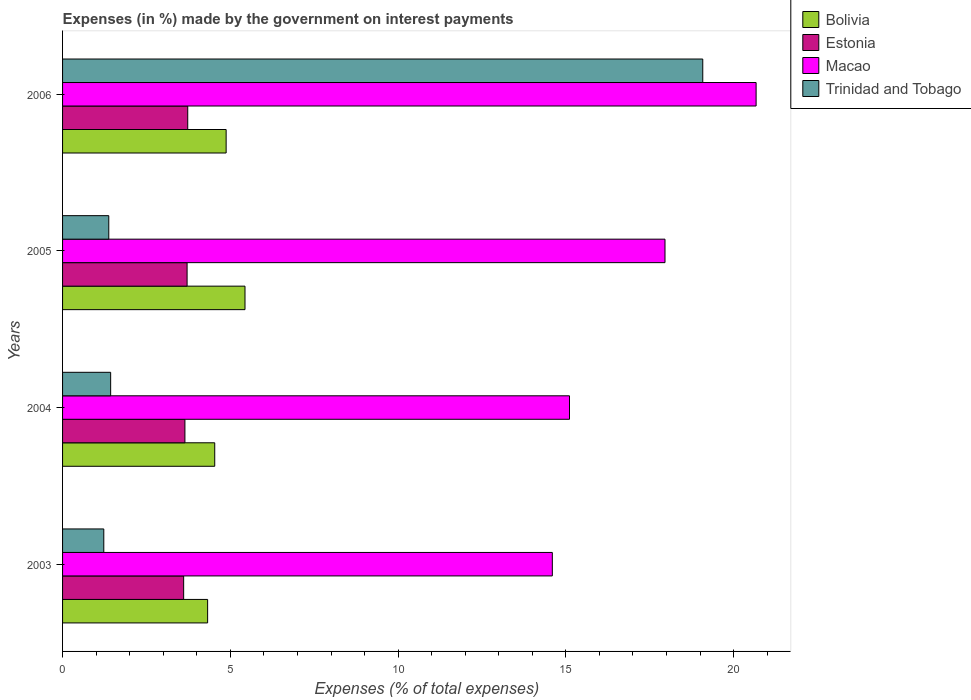How many bars are there on the 4th tick from the top?
Offer a very short reply. 4. How many bars are there on the 2nd tick from the bottom?
Offer a very short reply. 4. What is the label of the 4th group of bars from the top?
Offer a very short reply. 2003. In how many cases, is the number of bars for a given year not equal to the number of legend labels?
Your answer should be very brief. 0. What is the percentage of expenses made by the government on interest payments in Trinidad and Tobago in 2005?
Your response must be concise. 1.38. Across all years, what is the maximum percentage of expenses made by the government on interest payments in Macao?
Your answer should be very brief. 20.67. Across all years, what is the minimum percentage of expenses made by the government on interest payments in Estonia?
Offer a terse response. 3.61. In which year was the percentage of expenses made by the government on interest payments in Trinidad and Tobago maximum?
Your answer should be very brief. 2006. What is the total percentage of expenses made by the government on interest payments in Estonia in the graph?
Provide a succinct answer. 14.7. What is the difference between the percentage of expenses made by the government on interest payments in Trinidad and Tobago in 2003 and that in 2006?
Make the answer very short. -17.85. What is the difference between the percentage of expenses made by the government on interest payments in Trinidad and Tobago in 2006 and the percentage of expenses made by the government on interest payments in Macao in 2003?
Offer a terse response. 4.48. What is the average percentage of expenses made by the government on interest payments in Estonia per year?
Provide a succinct answer. 3.67. In the year 2005, what is the difference between the percentage of expenses made by the government on interest payments in Macao and percentage of expenses made by the government on interest payments in Bolivia?
Offer a very short reply. 12.52. What is the ratio of the percentage of expenses made by the government on interest payments in Macao in 2004 to that in 2005?
Give a very brief answer. 0.84. What is the difference between the highest and the second highest percentage of expenses made by the government on interest payments in Trinidad and Tobago?
Offer a terse response. 17.65. What is the difference between the highest and the lowest percentage of expenses made by the government on interest payments in Macao?
Give a very brief answer. 6.07. Is the sum of the percentage of expenses made by the government on interest payments in Estonia in 2003 and 2005 greater than the maximum percentage of expenses made by the government on interest payments in Bolivia across all years?
Ensure brevity in your answer.  Yes. How many bars are there?
Provide a succinct answer. 16. How many years are there in the graph?
Ensure brevity in your answer.  4. What is the difference between two consecutive major ticks on the X-axis?
Give a very brief answer. 5. Does the graph contain any zero values?
Offer a terse response. No. What is the title of the graph?
Make the answer very short. Expenses (in %) made by the government on interest payments. Does "Middle East & North Africa (all income levels)" appear as one of the legend labels in the graph?
Provide a short and direct response. No. What is the label or title of the X-axis?
Your answer should be compact. Expenses (% of total expenses). What is the label or title of the Y-axis?
Your answer should be compact. Years. What is the Expenses (% of total expenses) of Bolivia in 2003?
Make the answer very short. 4.32. What is the Expenses (% of total expenses) of Estonia in 2003?
Keep it short and to the point. 3.61. What is the Expenses (% of total expenses) of Macao in 2003?
Offer a very short reply. 14.6. What is the Expenses (% of total expenses) in Trinidad and Tobago in 2003?
Give a very brief answer. 1.23. What is the Expenses (% of total expenses) in Bolivia in 2004?
Offer a very short reply. 4.53. What is the Expenses (% of total expenses) of Estonia in 2004?
Give a very brief answer. 3.65. What is the Expenses (% of total expenses) in Macao in 2004?
Make the answer very short. 15.11. What is the Expenses (% of total expenses) in Trinidad and Tobago in 2004?
Offer a very short reply. 1.43. What is the Expenses (% of total expenses) of Bolivia in 2005?
Keep it short and to the point. 5.44. What is the Expenses (% of total expenses) in Estonia in 2005?
Offer a terse response. 3.71. What is the Expenses (% of total expenses) in Macao in 2005?
Offer a terse response. 17.95. What is the Expenses (% of total expenses) of Trinidad and Tobago in 2005?
Your answer should be very brief. 1.38. What is the Expenses (% of total expenses) of Bolivia in 2006?
Give a very brief answer. 4.87. What is the Expenses (% of total expenses) in Estonia in 2006?
Provide a short and direct response. 3.73. What is the Expenses (% of total expenses) in Macao in 2006?
Give a very brief answer. 20.67. What is the Expenses (% of total expenses) in Trinidad and Tobago in 2006?
Offer a very short reply. 19.08. Across all years, what is the maximum Expenses (% of total expenses) of Bolivia?
Your answer should be very brief. 5.44. Across all years, what is the maximum Expenses (% of total expenses) in Estonia?
Make the answer very short. 3.73. Across all years, what is the maximum Expenses (% of total expenses) of Macao?
Provide a short and direct response. 20.67. Across all years, what is the maximum Expenses (% of total expenses) in Trinidad and Tobago?
Give a very brief answer. 19.08. Across all years, what is the minimum Expenses (% of total expenses) of Bolivia?
Ensure brevity in your answer.  4.32. Across all years, what is the minimum Expenses (% of total expenses) of Estonia?
Offer a very short reply. 3.61. Across all years, what is the minimum Expenses (% of total expenses) in Macao?
Provide a short and direct response. 14.6. Across all years, what is the minimum Expenses (% of total expenses) in Trinidad and Tobago?
Offer a very short reply. 1.23. What is the total Expenses (% of total expenses) of Bolivia in the graph?
Ensure brevity in your answer.  19.17. What is the total Expenses (% of total expenses) in Estonia in the graph?
Make the answer very short. 14.7. What is the total Expenses (% of total expenses) in Macao in the graph?
Provide a short and direct response. 68.33. What is the total Expenses (% of total expenses) of Trinidad and Tobago in the graph?
Your answer should be compact. 23.12. What is the difference between the Expenses (% of total expenses) of Bolivia in 2003 and that in 2004?
Provide a succinct answer. -0.21. What is the difference between the Expenses (% of total expenses) of Estonia in 2003 and that in 2004?
Give a very brief answer. -0.04. What is the difference between the Expenses (% of total expenses) of Macao in 2003 and that in 2004?
Make the answer very short. -0.51. What is the difference between the Expenses (% of total expenses) in Trinidad and Tobago in 2003 and that in 2004?
Provide a succinct answer. -0.2. What is the difference between the Expenses (% of total expenses) in Bolivia in 2003 and that in 2005?
Your answer should be very brief. -1.11. What is the difference between the Expenses (% of total expenses) in Estonia in 2003 and that in 2005?
Keep it short and to the point. -0.1. What is the difference between the Expenses (% of total expenses) of Macao in 2003 and that in 2005?
Your answer should be compact. -3.36. What is the difference between the Expenses (% of total expenses) in Trinidad and Tobago in 2003 and that in 2005?
Your answer should be very brief. -0.15. What is the difference between the Expenses (% of total expenses) in Bolivia in 2003 and that in 2006?
Your response must be concise. -0.55. What is the difference between the Expenses (% of total expenses) in Estonia in 2003 and that in 2006?
Offer a terse response. -0.12. What is the difference between the Expenses (% of total expenses) in Macao in 2003 and that in 2006?
Your response must be concise. -6.07. What is the difference between the Expenses (% of total expenses) of Trinidad and Tobago in 2003 and that in 2006?
Ensure brevity in your answer.  -17.85. What is the difference between the Expenses (% of total expenses) in Bolivia in 2004 and that in 2005?
Provide a succinct answer. -0.9. What is the difference between the Expenses (% of total expenses) of Estonia in 2004 and that in 2005?
Your answer should be compact. -0.06. What is the difference between the Expenses (% of total expenses) of Macao in 2004 and that in 2005?
Provide a short and direct response. -2.85. What is the difference between the Expenses (% of total expenses) of Trinidad and Tobago in 2004 and that in 2005?
Provide a succinct answer. 0.06. What is the difference between the Expenses (% of total expenses) in Bolivia in 2004 and that in 2006?
Keep it short and to the point. -0.34. What is the difference between the Expenses (% of total expenses) of Estonia in 2004 and that in 2006?
Offer a very short reply. -0.08. What is the difference between the Expenses (% of total expenses) of Macao in 2004 and that in 2006?
Offer a terse response. -5.56. What is the difference between the Expenses (% of total expenses) of Trinidad and Tobago in 2004 and that in 2006?
Give a very brief answer. -17.65. What is the difference between the Expenses (% of total expenses) of Bolivia in 2005 and that in 2006?
Keep it short and to the point. 0.56. What is the difference between the Expenses (% of total expenses) in Estonia in 2005 and that in 2006?
Ensure brevity in your answer.  -0.02. What is the difference between the Expenses (% of total expenses) of Macao in 2005 and that in 2006?
Offer a terse response. -2.72. What is the difference between the Expenses (% of total expenses) in Trinidad and Tobago in 2005 and that in 2006?
Your answer should be compact. -17.7. What is the difference between the Expenses (% of total expenses) in Bolivia in 2003 and the Expenses (% of total expenses) in Estonia in 2004?
Ensure brevity in your answer.  0.68. What is the difference between the Expenses (% of total expenses) in Bolivia in 2003 and the Expenses (% of total expenses) in Macao in 2004?
Offer a terse response. -10.79. What is the difference between the Expenses (% of total expenses) of Bolivia in 2003 and the Expenses (% of total expenses) of Trinidad and Tobago in 2004?
Keep it short and to the point. 2.89. What is the difference between the Expenses (% of total expenses) of Estonia in 2003 and the Expenses (% of total expenses) of Macao in 2004?
Offer a very short reply. -11.5. What is the difference between the Expenses (% of total expenses) of Estonia in 2003 and the Expenses (% of total expenses) of Trinidad and Tobago in 2004?
Provide a short and direct response. 2.18. What is the difference between the Expenses (% of total expenses) of Macao in 2003 and the Expenses (% of total expenses) of Trinidad and Tobago in 2004?
Provide a succinct answer. 13.16. What is the difference between the Expenses (% of total expenses) of Bolivia in 2003 and the Expenses (% of total expenses) of Estonia in 2005?
Offer a terse response. 0.61. What is the difference between the Expenses (% of total expenses) of Bolivia in 2003 and the Expenses (% of total expenses) of Macao in 2005?
Make the answer very short. -13.63. What is the difference between the Expenses (% of total expenses) in Bolivia in 2003 and the Expenses (% of total expenses) in Trinidad and Tobago in 2005?
Give a very brief answer. 2.95. What is the difference between the Expenses (% of total expenses) in Estonia in 2003 and the Expenses (% of total expenses) in Macao in 2005?
Provide a short and direct response. -14.35. What is the difference between the Expenses (% of total expenses) in Estonia in 2003 and the Expenses (% of total expenses) in Trinidad and Tobago in 2005?
Make the answer very short. 2.23. What is the difference between the Expenses (% of total expenses) of Macao in 2003 and the Expenses (% of total expenses) of Trinidad and Tobago in 2005?
Provide a short and direct response. 13.22. What is the difference between the Expenses (% of total expenses) of Bolivia in 2003 and the Expenses (% of total expenses) of Estonia in 2006?
Keep it short and to the point. 0.59. What is the difference between the Expenses (% of total expenses) of Bolivia in 2003 and the Expenses (% of total expenses) of Macao in 2006?
Offer a terse response. -16.35. What is the difference between the Expenses (% of total expenses) in Bolivia in 2003 and the Expenses (% of total expenses) in Trinidad and Tobago in 2006?
Your answer should be compact. -14.76. What is the difference between the Expenses (% of total expenses) in Estonia in 2003 and the Expenses (% of total expenses) in Macao in 2006?
Your answer should be compact. -17.06. What is the difference between the Expenses (% of total expenses) of Estonia in 2003 and the Expenses (% of total expenses) of Trinidad and Tobago in 2006?
Offer a very short reply. -15.47. What is the difference between the Expenses (% of total expenses) in Macao in 2003 and the Expenses (% of total expenses) in Trinidad and Tobago in 2006?
Your answer should be very brief. -4.48. What is the difference between the Expenses (% of total expenses) in Bolivia in 2004 and the Expenses (% of total expenses) in Estonia in 2005?
Provide a succinct answer. 0.82. What is the difference between the Expenses (% of total expenses) of Bolivia in 2004 and the Expenses (% of total expenses) of Macao in 2005?
Your response must be concise. -13.42. What is the difference between the Expenses (% of total expenses) of Bolivia in 2004 and the Expenses (% of total expenses) of Trinidad and Tobago in 2005?
Give a very brief answer. 3.16. What is the difference between the Expenses (% of total expenses) of Estonia in 2004 and the Expenses (% of total expenses) of Macao in 2005?
Provide a succinct answer. -14.31. What is the difference between the Expenses (% of total expenses) of Estonia in 2004 and the Expenses (% of total expenses) of Trinidad and Tobago in 2005?
Make the answer very short. 2.27. What is the difference between the Expenses (% of total expenses) in Macao in 2004 and the Expenses (% of total expenses) in Trinidad and Tobago in 2005?
Keep it short and to the point. 13.73. What is the difference between the Expenses (% of total expenses) in Bolivia in 2004 and the Expenses (% of total expenses) in Estonia in 2006?
Provide a succinct answer. 0.8. What is the difference between the Expenses (% of total expenses) in Bolivia in 2004 and the Expenses (% of total expenses) in Macao in 2006?
Your response must be concise. -16.13. What is the difference between the Expenses (% of total expenses) of Bolivia in 2004 and the Expenses (% of total expenses) of Trinidad and Tobago in 2006?
Give a very brief answer. -14.54. What is the difference between the Expenses (% of total expenses) in Estonia in 2004 and the Expenses (% of total expenses) in Macao in 2006?
Ensure brevity in your answer.  -17.02. What is the difference between the Expenses (% of total expenses) of Estonia in 2004 and the Expenses (% of total expenses) of Trinidad and Tobago in 2006?
Offer a very short reply. -15.43. What is the difference between the Expenses (% of total expenses) of Macao in 2004 and the Expenses (% of total expenses) of Trinidad and Tobago in 2006?
Provide a succinct answer. -3.97. What is the difference between the Expenses (% of total expenses) of Bolivia in 2005 and the Expenses (% of total expenses) of Estonia in 2006?
Provide a short and direct response. 1.71. What is the difference between the Expenses (% of total expenses) in Bolivia in 2005 and the Expenses (% of total expenses) in Macao in 2006?
Provide a succinct answer. -15.23. What is the difference between the Expenses (% of total expenses) in Bolivia in 2005 and the Expenses (% of total expenses) in Trinidad and Tobago in 2006?
Offer a very short reply. -13.64. What is the difference between the Expenses (% of total expenses) in Estonia in 2005 and the Expenses (% of total expenses) in Macao in 2006?
Ensure brevity in your answer.  -16.96. What is the difference between the Expenses (% of total expenses) in Estonia in 2005 and the Expenses (% of total expenses) in Trinidad and Tobago in 2006?
Your answer should be very brief. -15.37. What is the difference between the Expenses (% of total expenses) in Macao in 2005 and the Expenses (% of total expenses) in Trinidad and Tobago in 2006?
Give a very brief answer. -1.13. What is the average Expenses (% of total expenses) of Bolivia per year?
Your answer should be very brief. 4.79. What is the average Expenses (% of total expenses) of Estonia per year?
Offer a very short reply. 3.67. What is the average Expenses (% of total expenses) of Macao per year?
Keep it short and to the point. 17.08. What is the average Expenses (% of total expenses) of Trinidad and Tobago per year?
Your answer should be compact. 5.78. In the year 2003, what is the difference between the Expenses (% of total expenses) of Bolivia and Expenses (% of total expenses) of Estonia?
Your response must be concise. 0.71. In the year 2003, what is the difference between the Expenses (% of total expenses) of Bolivia and Expenses (% of total expenses) of Macao?
Offer a terse response. -10.27. In the year 2003, what is the difference between the Expenses (% of total expenses) of Bolivia and Expenses (% of total expenses) of Trinidad and Tobago?
Provide a succinct answer. 3.09. In the year 2003, what is the difference between the Expenses (% of total expenses) in Estonia and Expenses (% of total expenses) in Macao?
Keep it short and to the point. -10.99. In the year 2003, what is the difference between the Expenses (% of total expenses) of Estonia and Expenses (% of total expenses) of Trinidad and Tobago?
Provide a short and direct response. 2.38. In the year 2003, what is the difference between the Expenses (% of total expenses) of Macao and Expenses (% of total expenses) of Trinidad and Tobago?
Give a very brief answer. 13.37. In the year 2004, what is the difference between the Expenses (% of total expenses) in Bolivia and Expenses (% of total expenses) in Estonia?
Make the answer very short. 0.89. In the year 2004, what is the difference between the Expenses (% of total expenses) in Bolivia and Expenses (% of total expenses) in Macao?
Your answer should be very brief. -10.57. In the year 2004, what is the difference between the Expenses (% of total expenses) of Bolivia and Expenses (% of total expenses) of Trinidad and Tobago?
Your answer should be very brief. 3.1. In the year 2004, what is the difference between the Expenses (% of total expenses) of Estonia and Expenses (% of total expenses) of Macao?
Give a very brief answer. -11.46. In the year 2004, what is the difference between the Expenses (% of total expenses) in Estonia and Expenses (% of total expenses) in Trinidad and Tobago?
Provide a succinct answer. 2.21. In the year 2004, what is the difference between the Expenses (% of total expenses) in Macao and Expenses (% of total expenses) in Trinidad and Tobago?
Your answer should be compact. 13.68. In the year 2005, what is the difference between the Expenses (% of total expenses) in Bolivia and Expenses (% of total expenses) in Estonia?
Provide a short and direct response. 1.73. In the year 2005, what is the difference between the Expenses (% of total expenses) of Bolivia and Expenses (% of total expenses) of Macao?
Your response must be concise. -12.52. In the year 2005, what is the difference between the Expenses (% of total expenses) of Bolivia and Expenses (% of total expenses) of Trinidad and Tobago?
Your answer should be compact. 4.06. In the year 2005, what is the difference between the Expenses (% of total expenses) of Estonia and Expenses (% of total expenses) of Macao?
Keep it short and to the point. -14.24. In the year 2005, what is the difference between the Expenses (% of total expenses) in Estonia and Expenses (% of total expenses) in Trinidad and Tobago?
Provide a short and direct response. 2.33. In the year 2005, what is the difference between the Expenses (% of total expenses) of Macao and Expenses (% of total expenses) of Trinidad and Tobago?
Provide a succinct answer. 16.58. In the year 2006, what is the difference between the Expenses (% of total expenses) of Bolivia and Expenses (% of total expenses) of Estonia?
Make the answer very short. 1.14. In the year 2006, what is the difference between the Expenses (% of total expenses) in Bolivia and Expenses (% of total expenses) in Macao?
Your response must be concise. -15.79. In the year 2006, what is the difference between the Expenses (% of total expenses) of Bolivia and Expenses (% of total expenses) of Trinidad and Tobago?
Make the answer very short. -14.2. In the year 2006, what is the difference between the Expenses (% of total expenses) in Estonia and Expenses (% of total expenses) in Macao?
Make the answer very short. -16.94. In the year 2006, what is the difference between the Expenses (% of total expenses) in Estonia and Expenses (% of total expenses) in Trinidad and Tobago?
Keep it short and to the point. -15.35. In the year 2006, what is the difference between the Expenses (% of total expenses) of Macao and Expenses (% of total expenses) of Trinidad and Tobago?
Provide a succinct answer. 1.59. What is the ratio of the Expenses (% of total expenses) of Bolivia in 2003 to that in 2004?
Provide a short and direct response. 0.95. What is the ratio of the Expenses (% of total expenses) in Macao in 2003 to that in 2004?
Offer a very short reply. 0.97. What is the ratio of the Expenses (% of total expenses) of Trinidad and Tobago in 2003 to that in 2004?
Offer a very short reply. 0.86. What is the ratio of the Expenses (% of total expenses) of Bolivia in 2003 to that in 2005?
Ensure brevity in your answer.  0.8. What is the ratio of the Expenses (% of total expenses) of Estonia in 2003 to that in 2005?
Provide a succinct answer. 0.97. What is the ratio of the Expenses (% of total expenses) in Macao in 2003 to that in 2005?
Your answer should be compact. 0.81. What is the ratio of the Expenses (% of total expenses) of Trinidad and Tobago in 2003 to that in 2005?
Offer a very short reply. 0.89. What is the ratio of the Expenses (% of total expenses) in Bolivia in 2003 to that in 2006?
Give a very brief answer. 0.89. What is the ratio of the Expenses (% of total expenses) of Estonia in 2003 to that in 2006?
Make the answer very short. 0.97. What is the ratio of the Expenses (% of total expenses) in Macao in 2003 to that in 2006?
Give a very brief answer. 0.71. What is the ratio of the Expenses (% of total expenses) in Trinidad and Tobago in 2003 to that in 2006?
Keep it short and to the point. 0.06. What is the ratio of the Expenses (% of total expenses) of Bolivia in 2004 to that in 2005?
Provide a short and direct response. 0.83. What is the ratio of the Expenses (% of total expenses) in Estonia in 2004 to that in 2005?
Make the answer very short. 0.98. What is the ratio of the Expenses (% of total expenses) in Macao in 2004 to that in 2005?
Offer a very short reply. 0.84. What is the ratio of the Expenses (% of total expenses) in Trinidad and Tobago in 2004 to that in 2005?
Give a very brief answer. 1.04. What is the ratio of the Expenses (% of total expenses) of Bolivia in 2004 to that in 2006?
Your answer should be compact. 0.93. What is the ratio of the Expenses (% of total expenses) in Estonia in 2004 to that in 2006?
Your answer should be compact. 0.98. What is the ratio of the Expenses (% of total expenses) in Macao in 2004 to that in 2006?
Provide a short and direct response. 0.73. What is the ratio of the Expenses (% of total expenses) of Trinidad and Tobago in 2004 to that in 2006?
Provide a short and direct response. 0.08. What is the ratio of the Expenses (% of total expenses) in Bolivia in 2005 to that in 2006?
Provide a short and direct response. 1.12. What is the ratio of the Expenses (% of total expenses) in Macao in 2005 to that in 2006?
Your response must be concise. 0.87. What is the ratio of the Expenses (% of total expenses) of Trinidad and Tobago in 2005 to that in 2006?
Offer a terse response. 0.07. What is the difference between the highest and the second highest Expenses (% of total expenses) of Bolivia?
Offer a very short reply. 0.56. What is the difference between the highest and the second highest Expenses (% of total expenses) of Estonia?
Offer a very short reply. 0.02. What is the difference between the highest and the second highest Expenses (% of total expenses) of Macao?
Make the answer very short. 2.72. What is the difference between the highest and the second highest Expenses (% of total expenses) in Trinidad and Tobago?
Keep it short and to the point. 17.65. What is the difference between the highest and the lowest Expenses (% of total expenses) of Bolivia?
Give a very brief answer. 1.11. What is the difference between the highest and the lowest Expenses (% of total expenses) in Estonia?
Make the answer very short. 0.12. What is the difference between the highest and the lowest Expenses (% of total expenses) of Macao?
Ensure brevity in your answer.  6.07. What is the difference between the highest and the lowest Expenses (% of total expenses) in Trinidad and Tobago?
Offer a very short reply. 17.85. 